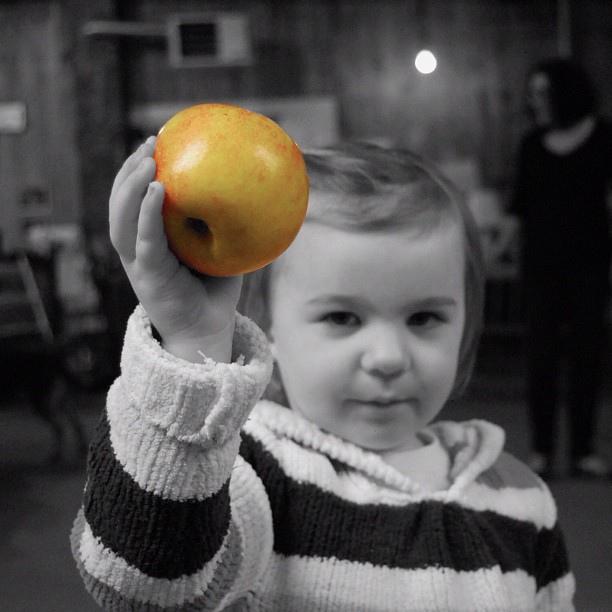What is the name for the clothing the child is wearing?
Concise answer only. Sweater. What is the kid holding that is orange?
Quick response, please. Apple. What is the child holding?
Write a very short answer. Apple. 